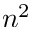<formula> <loc_0><loc_0><loc_500><loc_500>n ^ { 2 }</formula> 